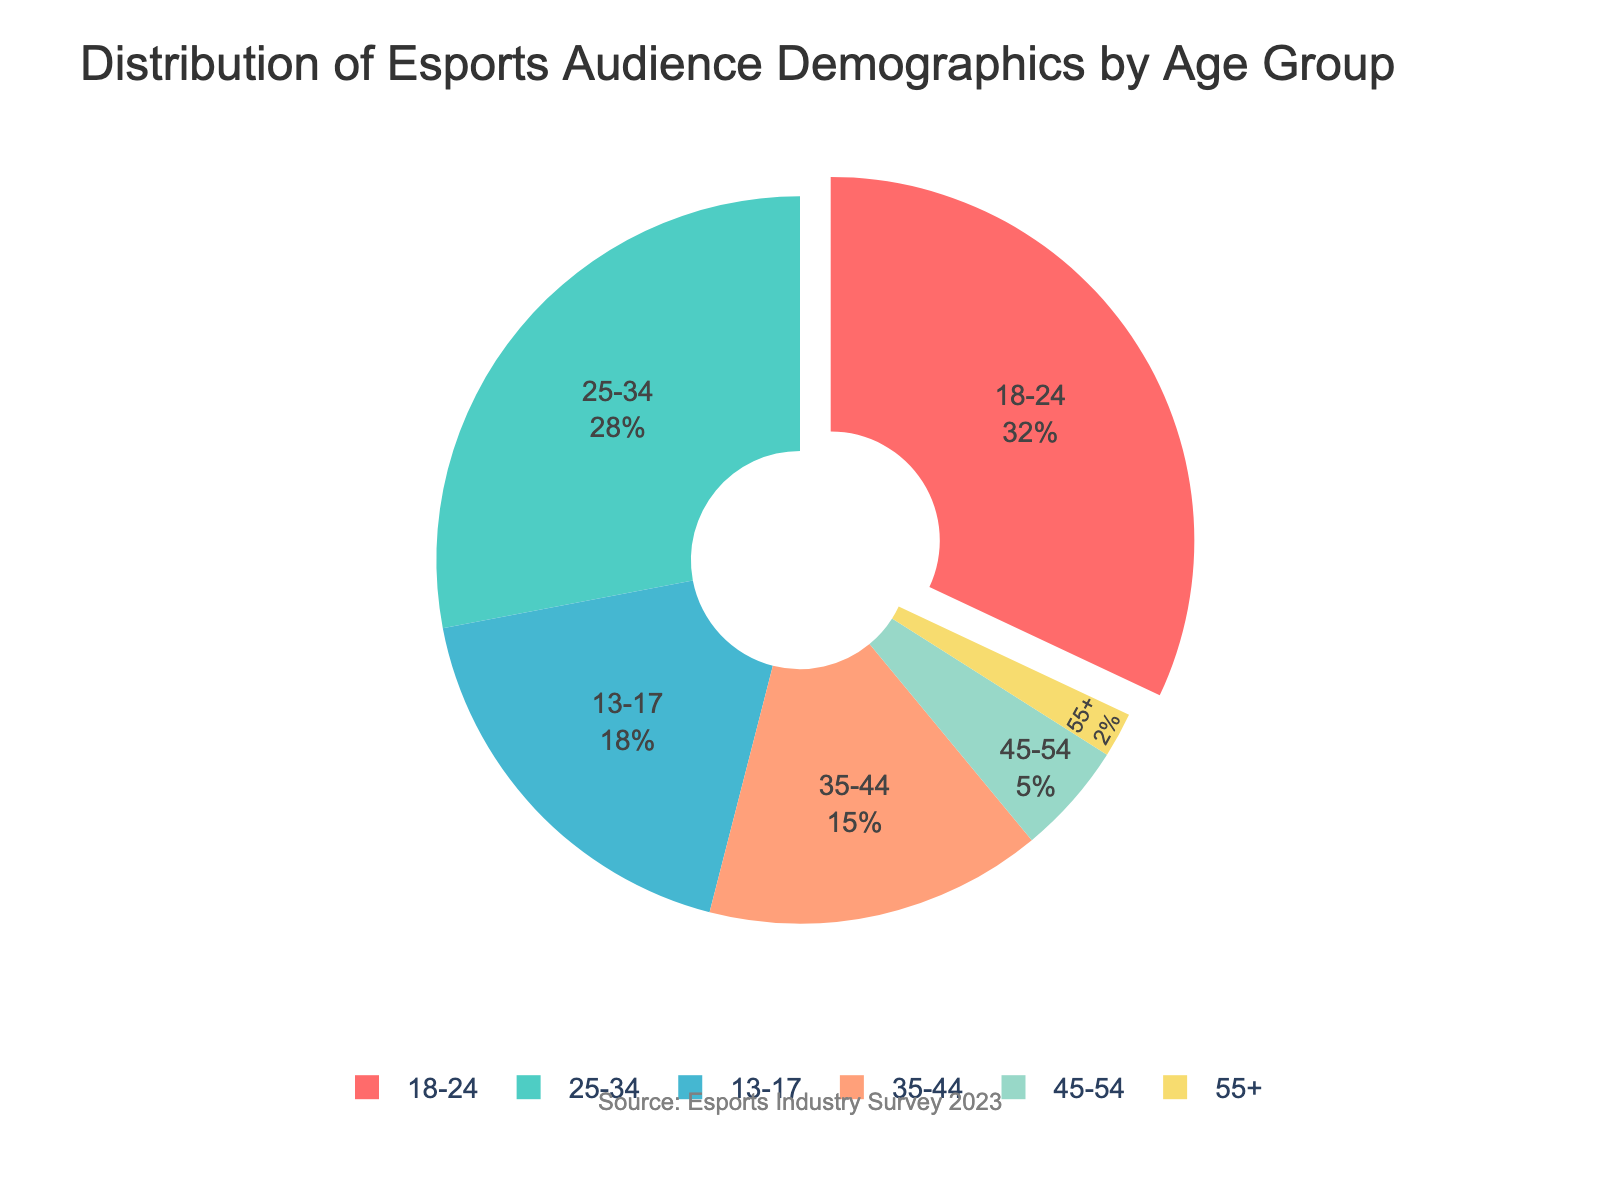Which age group has the highest percentage of the esports audience? To determine the age group with the highest percentage of the esports audience, observe the pie chart's largest segment.
Answer: 18-24 Which two age groups combined make up more than half of the esports audience? Look for the percentages of the age groups and find the combination that sums to over 50%. The 18-24 group is 32% and the 25-34 group is 28%, which together make 60%.
Answer: 18-24 and 25-34 By how much does the percentage of the 13-17 age group exceed that of the 35-44 age group? Subtract the percentage value of the 35-44 age group from that of the 13-17 age group (18% - 15%).
Answer: 3% What is the combined percentage of the esports audience aged 45 and over? Sum the percentages of the age groups 45-54 and 55+ (5% + 2%).
Answer: 7% Which age group represents the smallest segment in the esports audience pie chart? Identify the smallest segment in the chart.
Answer: 55+ Which two age groups have the smallest percentages combined? Find the smallest percentages and sum them: 55+ (2%) and 45-54 (5%).
Answer: 55+ and 45-54 What is the difference in percentage points between the age group 25-34 and the age group 55+ in the esports audience? Subtract the percentage value of the 55+ age group from that of the 25-34 age group (28% - 2%).
Answer: 26% How does the percentage of the 35-44 age group compare to the 13-17 age group? Compare the percentages directly: 15% for the 35-44 group versus 18% for the 13-17 group.
Answer: The 13-17 age group is 3% higher than the 35-44 age group What percentage of the audience falls under the age group 18-24? Directly refer to the pie chart where the percentage is shown.
Answer: 32% If you were to target marketing efforts at the two largest age groups, which ones would those be? Identify the two largest segments in the pie chart: 18-24 (32%) and 25-34 (28%).
Answer: 18-24 and 25-34 